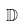<formula> <loc_0><loc_0><loc_500><loc_500>\mathbb { D }</formula> 